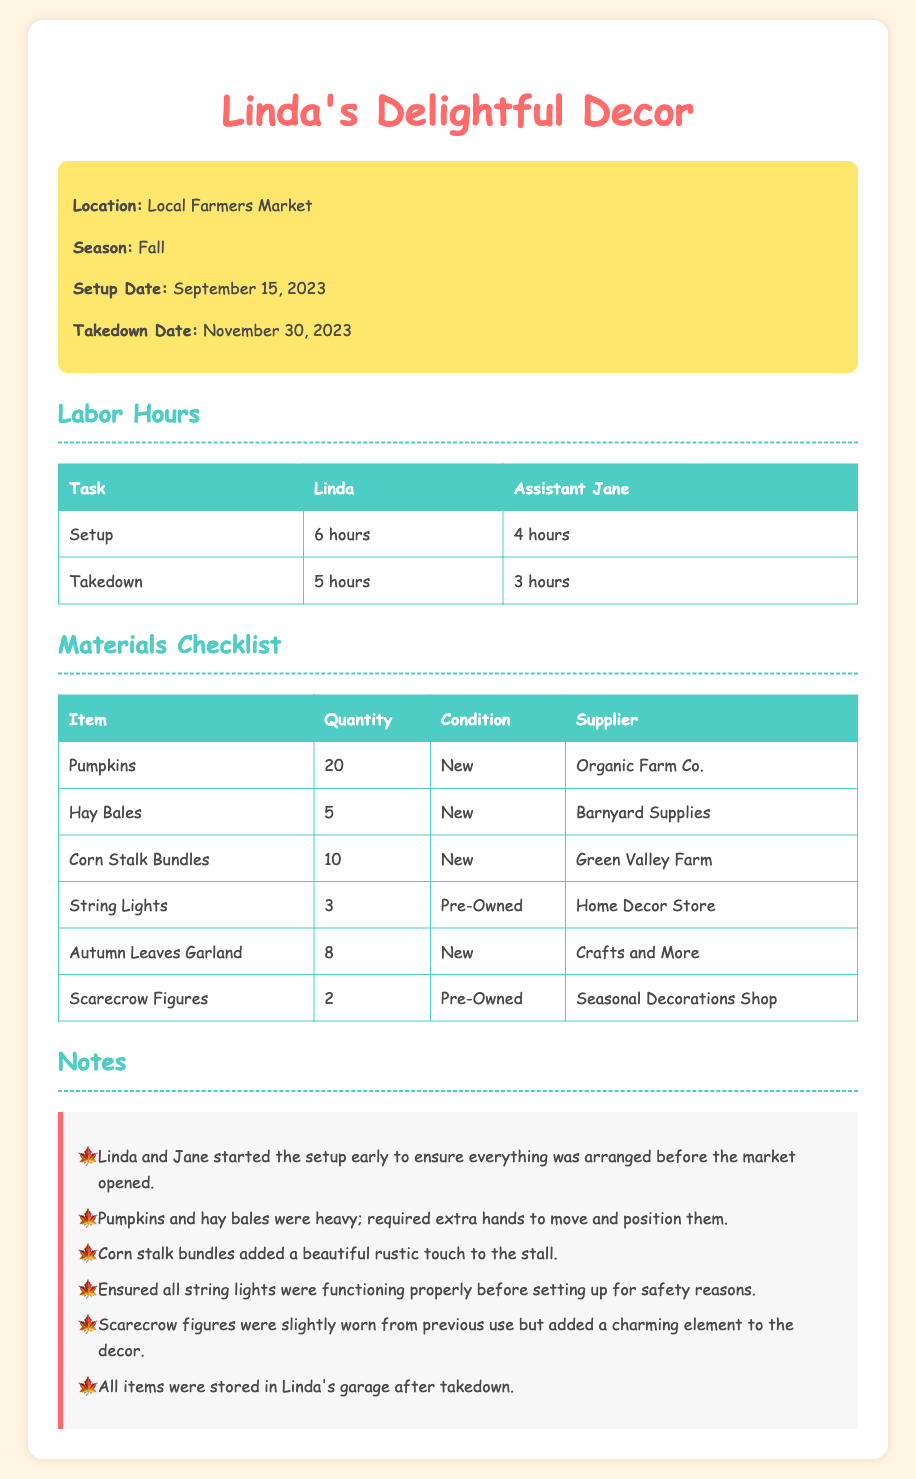What season is the decoration for? The document specifies that the season is Fall.
Answer: Fall What is the setup date? The setup date is mentioned as September 15, 2023.
Answer: September 15, 2023 How many hours did Linda spend on takedown? The document states that Linda spent 5 hours on takedown.
Answer: 5 hours How many pumpkins were prepared for decoration? The checklist indicates that 20 pumpkins were prepared.
Answer: 20 Which supplier provided the Autumn Leaves Garland? The supplier for the Autumn Leaves Garland is listed as Crafts and More.
Answer: Crafts and More What was the condition of the scarecrow figures? The document describes the condition of the scarecrow figures as Pre-Owned.
Answer: Pre-Owned How many total hours did Jane work on setup and takedown combined? Jane worked 4 hours on setup and 3 hours on takedown, totaling 7 hours.
Answer: 7 hours What item added a lovely rustic touch to the stall? The corn stalk bundles are noted for adding a beautiful rustic touch.
Answer: Corn Stalk Bundles Where were all items stored after takedown? The notes indicate that all items were stored in Linda's garage after takedown.
Answer: Linda's garage 